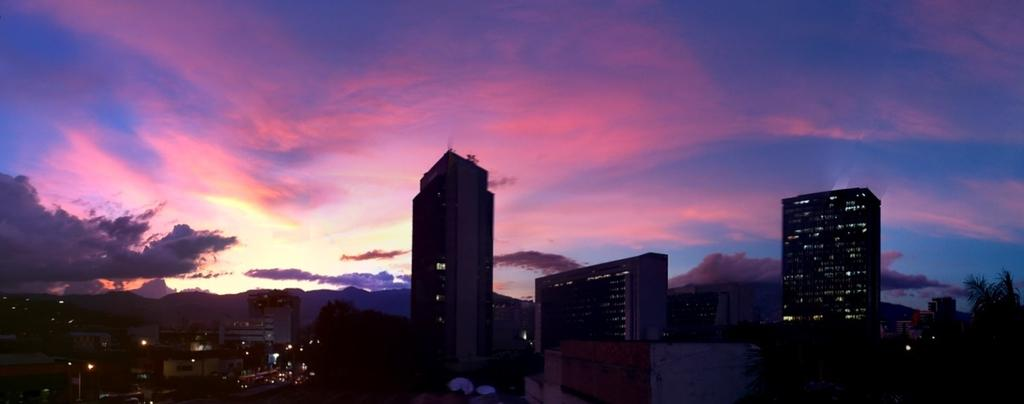What type of structures can be seen in the image? There are buildings in the image. What other natural elements are present in the image? There are trees in the image. Are there any artificial light sources visible in the image? Yes, there are lights visible in the image. What part of the natural environment is visible in the image? The sky is visible in the image. What type of texture can be seen on the buildings in the image? The provided facts do not mention any specific texture on the buildings, so it cannot be determined from the image. 